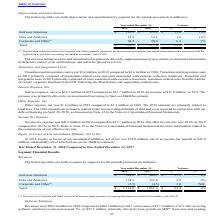According to Black Knight Financial Services's financial document, What did revenues for Corporate and Other represent? deferred revenue purchase accounting adjustments recorded in accordance with GAAP. The document states: "__ (1) Revenues for Corporate and Other represent deferred revenue purchase accounting adjustments recorded in accordance with GAAP...." Also, What was revenue from Software Solutions in 2018? According to the financial document, 962.0 (in millions). The relevant text states: "Software Solutions $ 962.0 $ 904.5 $ 57.5 6%..." Also, What was revenue from Data and Analytics in 2017? According to the financial document, 151.6 (in millions). The relevant text states: "Data and Analytics 154.5 151.6 2.9 2%..." Also, How many years did revenue from Data and Analytics exceed $150 million? Counting the relevant items in the document: 2018, 2017, I find 2 instances. The key data points involved are: 2017, 2018. Also, can you calculate: What was the average total revenue between 2017 and 2018? To answer this question, I need to perform calculations using the financial data. The calculation is: (1,114.0+1,051.6)/2, which equals 1082.8 (in millions). This is based on the information: "Total $ 1,114.0 $ 1,051.6 $ 62.4 6% Total $ 1,114.0 $ 1,051.6 $ 62.4 6%..." The key data points involved are: 1,051.6, 1,114.0. Also, can you calculate: What was the average revenue from Corporate and Other between 2017 and 2018? To answer this question, I need to perform calculations using the financial data. The calculation is: (-2.5+(-4.5))/2, which equals -3.5 (in millions). This is based on the information: "Software Solutions $ 962.0 $ 904.5 $ 57.5 6% Corporate and Other (1) (2.5) (4.5) 2.0 NM Corporate and Other (1) (2.5) (4.5) 2.0 NM..." The key data points involved are: 2, 2.5, 4.5. 